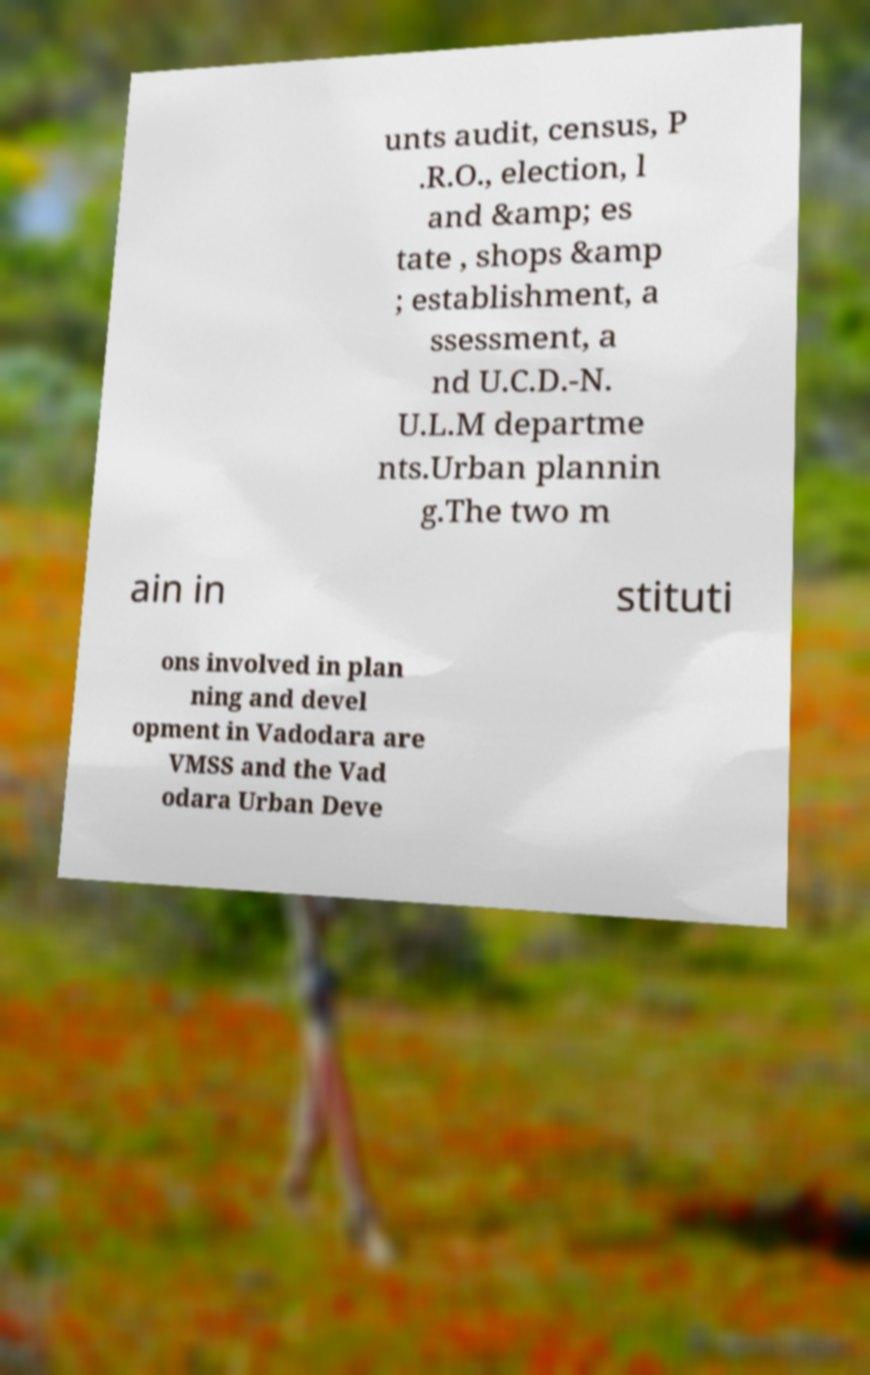Could you assist in decoding the text presented in this image and type it out clearly? unts audit, census, P .R.O., election, l and &amp; es tate , shops &amp ; establishment, a ssessment, a nd U.C.D.-N. U.L.M departme nts.Urban plannin g.The two m ain in stituti ons involved in plan ning and devel opment in Vadodara are VMSS and the Vad odara Urban Deve 